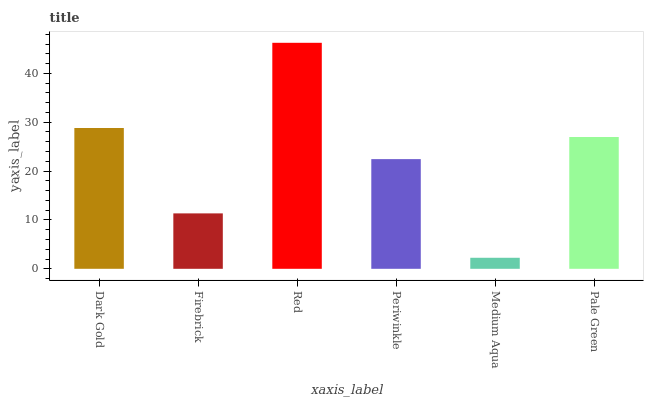Is Firebrick the minimum?
Answer yes or no. No. Is Firebrick the maximum?
Answer yes or no. No. Is Dark Gold greater than Firebrick?
Answer yes or no. Yes. Is Firebrick less than Dark Gold?
Answer yes or no. Yes. Is Firebrick greater than Dark Gold?
Answer yes or no. No. Is Dark Gold less than Firebrick?
Answer yes or no. No. Is Pale Green the high median?
Answer yes or no. Yes. Is Periwinkle the low median?
Answer yes or no. Yes. Is Red the high median?
Answer yes or no. No. Is Dark Gold the low median?
Answer yes or no. No. 